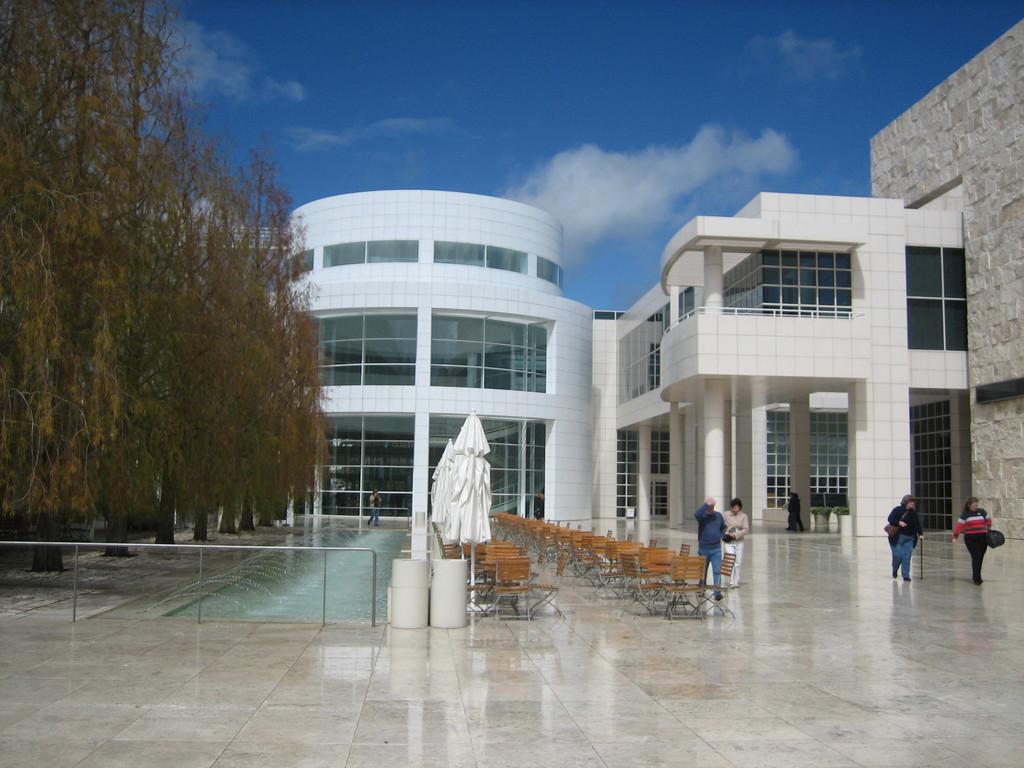In one or two sentences, can you explain what this image depicts? This is the picture of a building. On the right side of the image there are group of people walking and there are tables and chairs and umbrellas. At the back there is a building. On the left side of the image there are trees. At the top there is sky. At the bottom there is a fountain. 